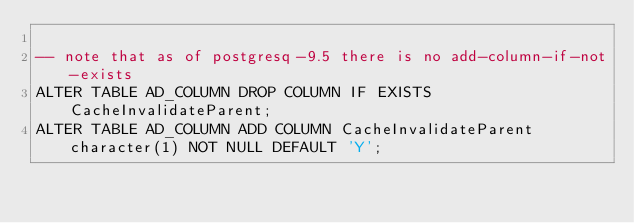Convert code to text. <code><loc_0><loc_0><loc_500><loc_500><_SQL_>
-- note that as of postgresq-9.5 there is no add-column-if-not-exists
ALTER TABLE AD_COLUMN DROP COLUMN IF EXISTS CacheInvalidateParent;
ALTER TABLE AD_COLUMN ADD COLUMN CacheInvalidateParent character(1) NOT NULL DEFAULT 'Y';
</code> 